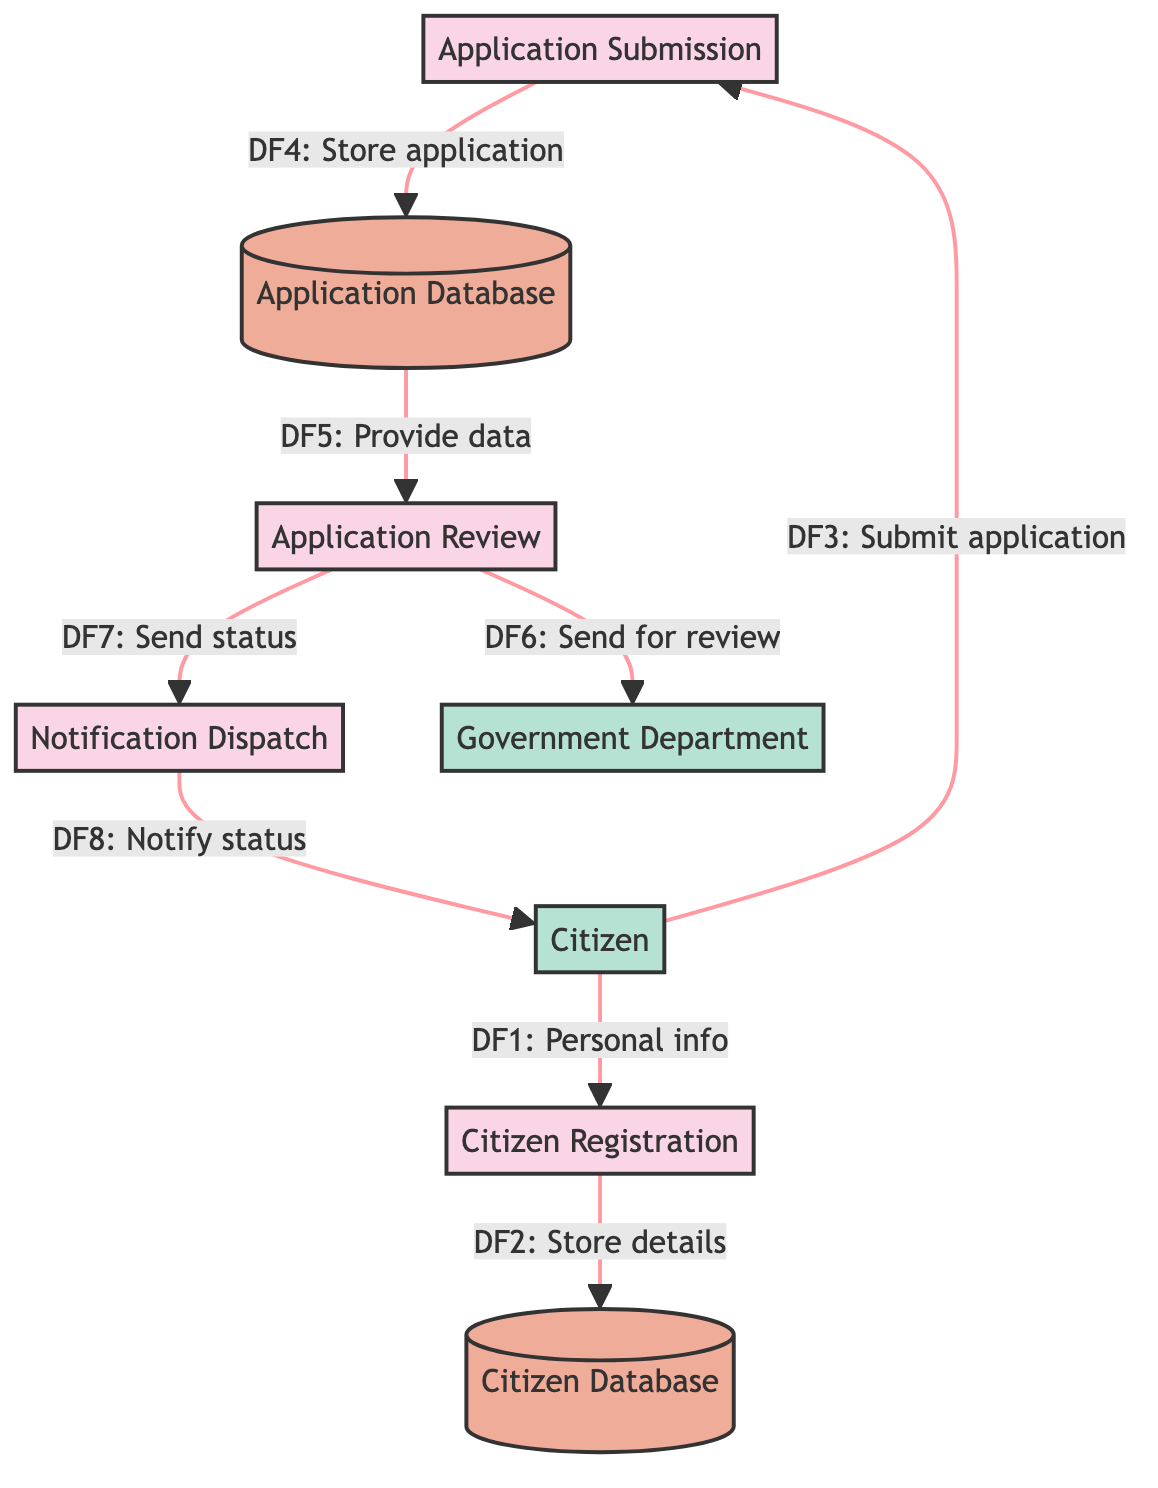What is the first process in the diagram? The first process in the diagram is "Citizen Registration," which is the initial step for citizens in accessing e-government services.
Answer: Citizen Registration How many data stores are present in the diagram? The diagram features two data stores: "Citizen Database" and "Application Database." Hence, the total is two.
Answer: 2 What is the role of the "Application Review" process? The "Application Review" process reviews and approves or rejects applications submitted by citizens for various e-government services.
Answer: Reviews applications Which external entity submits an application? The external entity that submits an application is the "Citizen." Citizens are the ones who access the e-government services and provide their applications.
Answer: Citizen How many flows are associated with the "Notification Dispatch"? There are two flows associated with the "Notification Dispatch": one for sending application status to the citizen and another for application status sent from the Application Review process.
Answer: 2 What information does the "Citizen Registration" process receive from the external entity? The "Citizen Registration" process receives personal information from the external entity, which is the Citizen providing their details for registration.
Answer: Personal information What happens after an application is submitted? After an application is submitted, the details of this application are stored in the "Application Database" for further processing and review.
Answer: Stored in Application Database Which process sends notifications to citizens? The process responsible for sending notifications to citizens about the status of their applications is "Notification Dispatch."
Answer: Notification Dispatch 